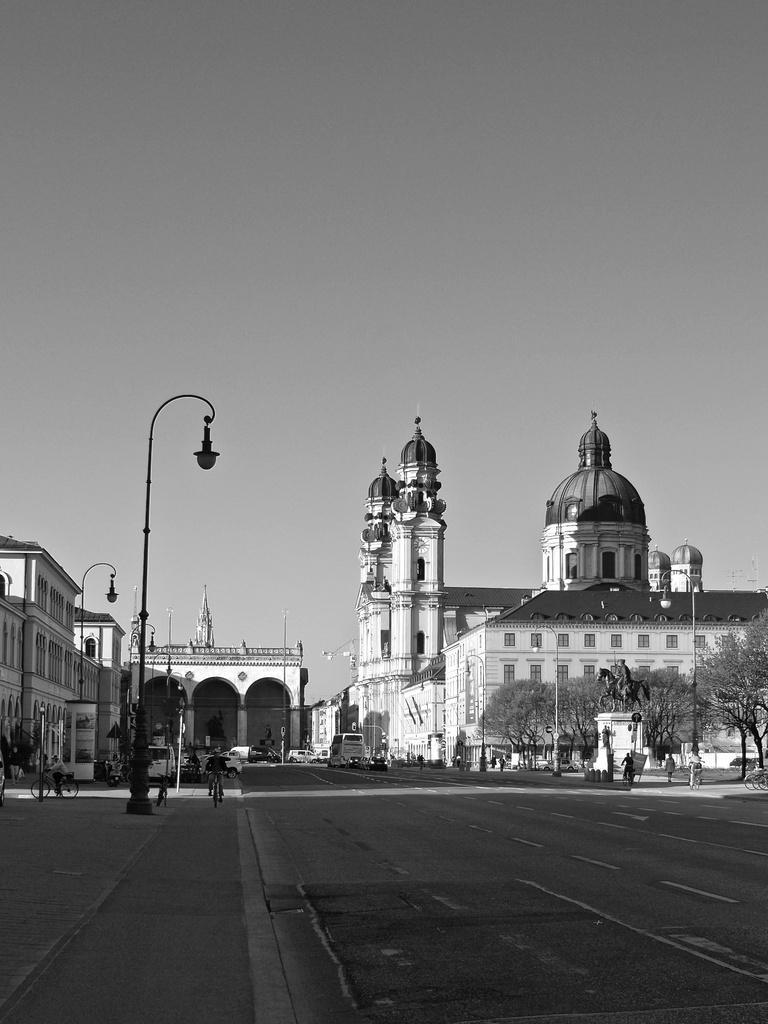Please provide a concise description of this image. In this picture I can see vehicles on the road, there are group of people, there are poles, lights, trees, buildings, there is a sculpture of a person sitting on the horse, and in the background there is sky. 